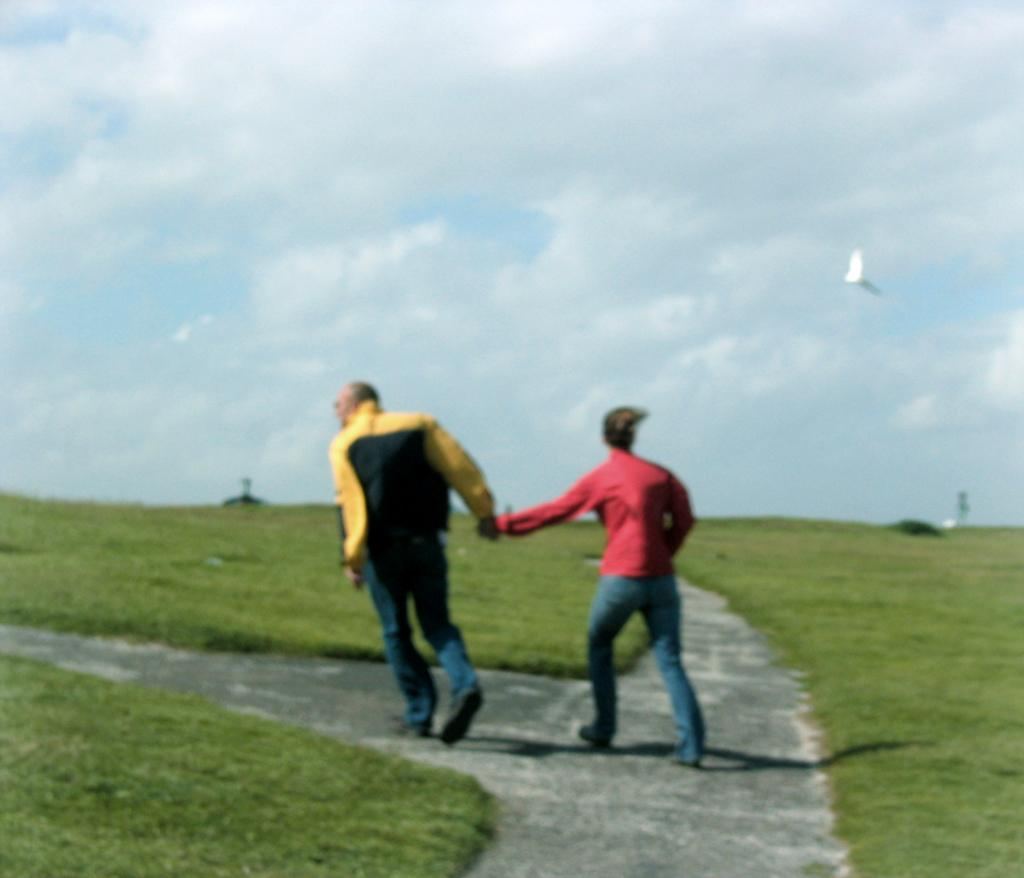Where was the image taken? The image was clicked outside. How many people are in the image? There are two men in the image. What can be seen on the right side of the image? There is a bird on the right side of the image. What type of vegetation is visible in the image? There is grass visible in the image. What is visible at the top of the image? The sky is visible at the top of the image. What type of liquid is being poured by the man in the image? There is no man pouring liquid in the image; it features two men and a bird. How many clocks are visible in the image? There are no clocks present in the image. 